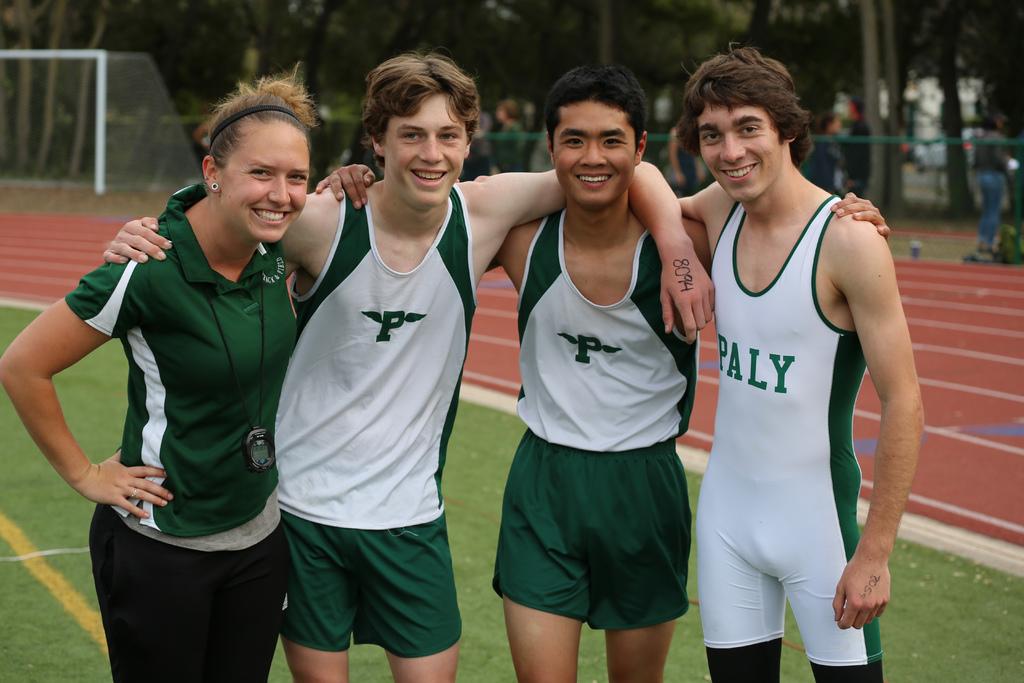What does the p stand for?
Make the answer very short. Paly. What number is written on his hand?
Offer a terse response. 8094. 